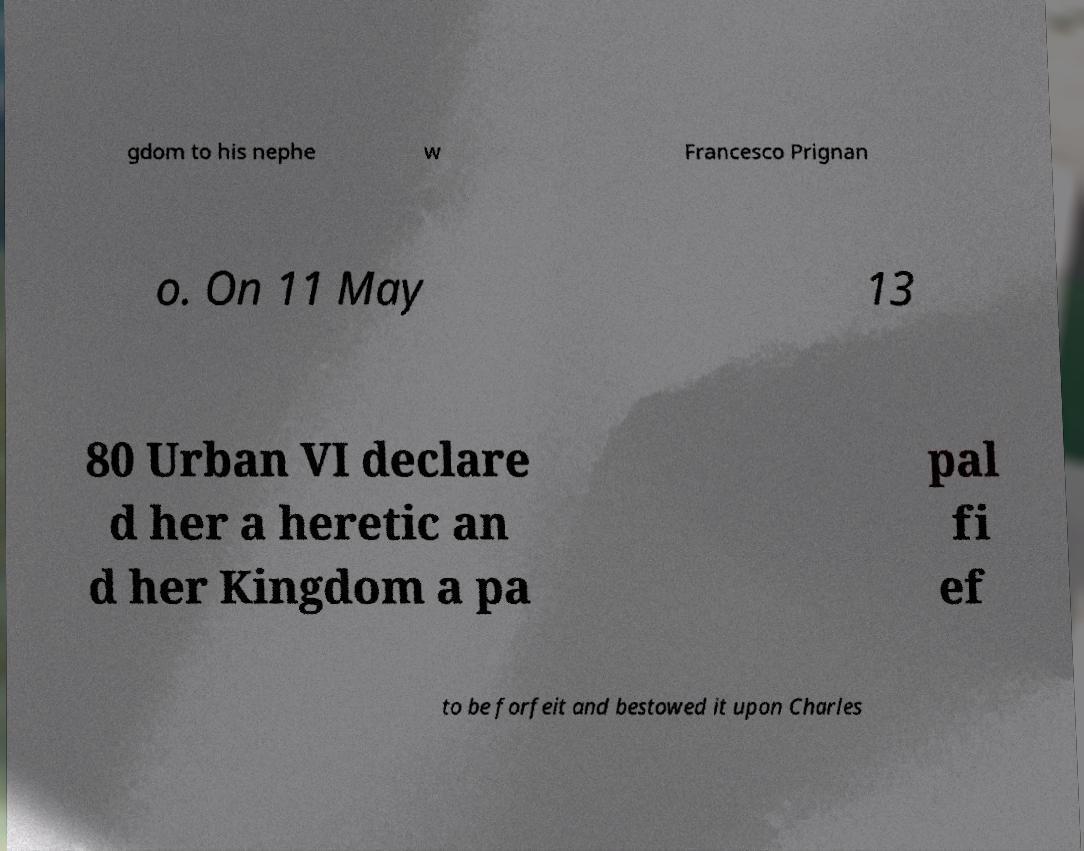For documentation purposes, I need the text within this image transcribed. Could you provide that? gdom to his nephe w Francesco Prignan o. On 11 May 13 80 Urban VI declare d her a heretic an d her Kingdom a pa pal fi ef to be forfeit and bestowed it upon Charles 